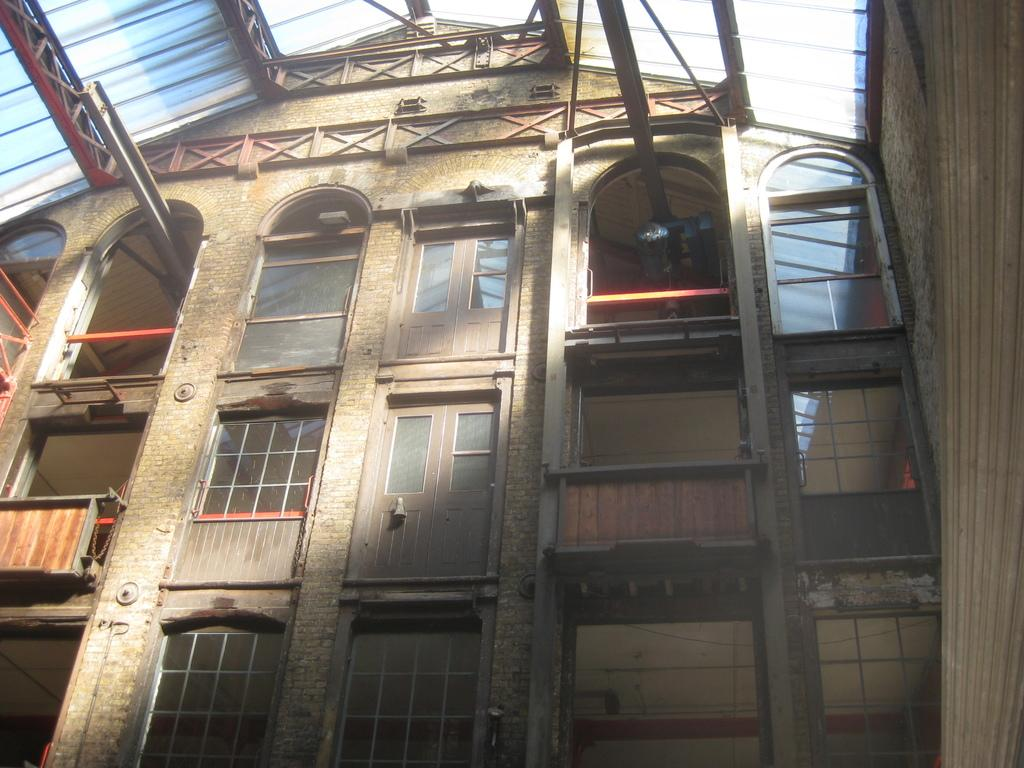What type of structure is present in the image? There is a building in the image. What are the main features of the building? The building has doors, windows, iron bars, a wall, and a roof. How many rabbits can be seen hopping around the building in the image? There are no rabbits present in the image. Can you tell me if the building sneezes in the image? Buildings do not have the ability to sneeze, so this cannot be observed in the image. 